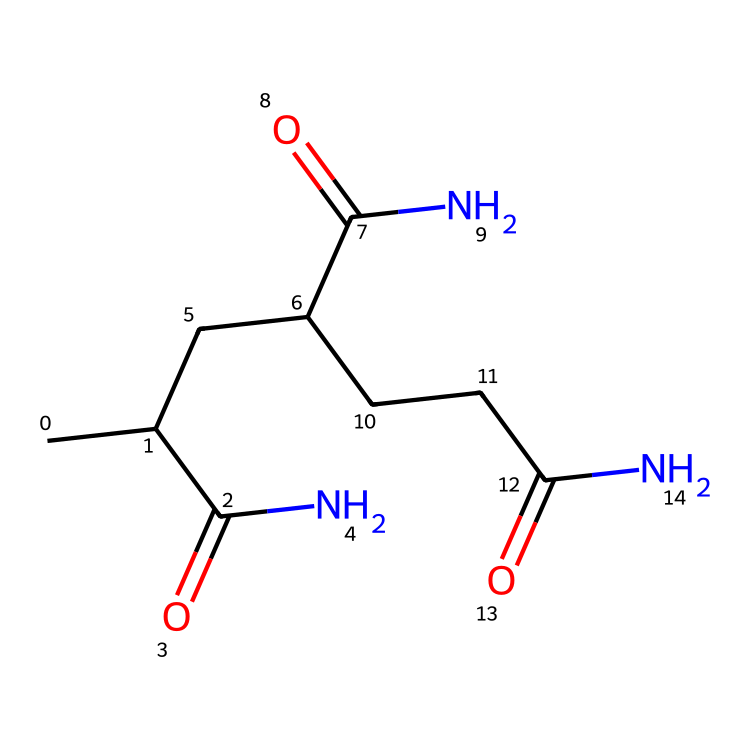what is the total number of carbon atoms in the structure? By examining the SMILES representation, we can count the carbon (C) atoms. The structure lists three carbon chain segments with three carbonyl groups, resulting in a total of nine carbon atoms.
Answer: nine how many carbonyl groups are present in the chemical? In the SMILES notation, "C(=O)" indicates a carbonyl group, and we see three instances of this in the structure. Therefore, there are three carbonyl groups.
Answer: three what type of non-Newtonian behavior is exhibited by polyacrylamide when mixed with soil? Polyacrylamide in soil typically exhibits shear-thinning behavior, meaning it becomes less viscous under applied shear stress, which helps to improve water retention in citrus orchard soil.
Answer: shear-thinning what type of polymer is represented by this structure? The arrangement includes repeating units of acrylamide, categorizing it as a synthetic polymer, specifically a superabsorbent polymer due to its ability to absorb water.
Answer: synthetic polymer how does the molecular structure of polyacrylamide contribute to its effectiveness as a soil conditioner? The long chains of polyacrylamide enable the formation of a gel-like consistency when hydrated, which traps water and nutrients in the soil, thereby enhancing moisture retention for plants.
Answer: gel does polyacrylamide have a high or low molecular weight? Polyacrylamide is characterized by a relatively high molecular weight due to the long-chain structure formed by the polymerization of acrylamide monomers, allowing for effective water retention.
Answer: high what is the state of polyacrylamide when mixed with water? When mixed with water, polyacrylamide forms a gel-like consistency, indicating that it is hydrophilic and can absorb significant amounts of water, facilitating soil moisture retention.
Answer: gel-like 